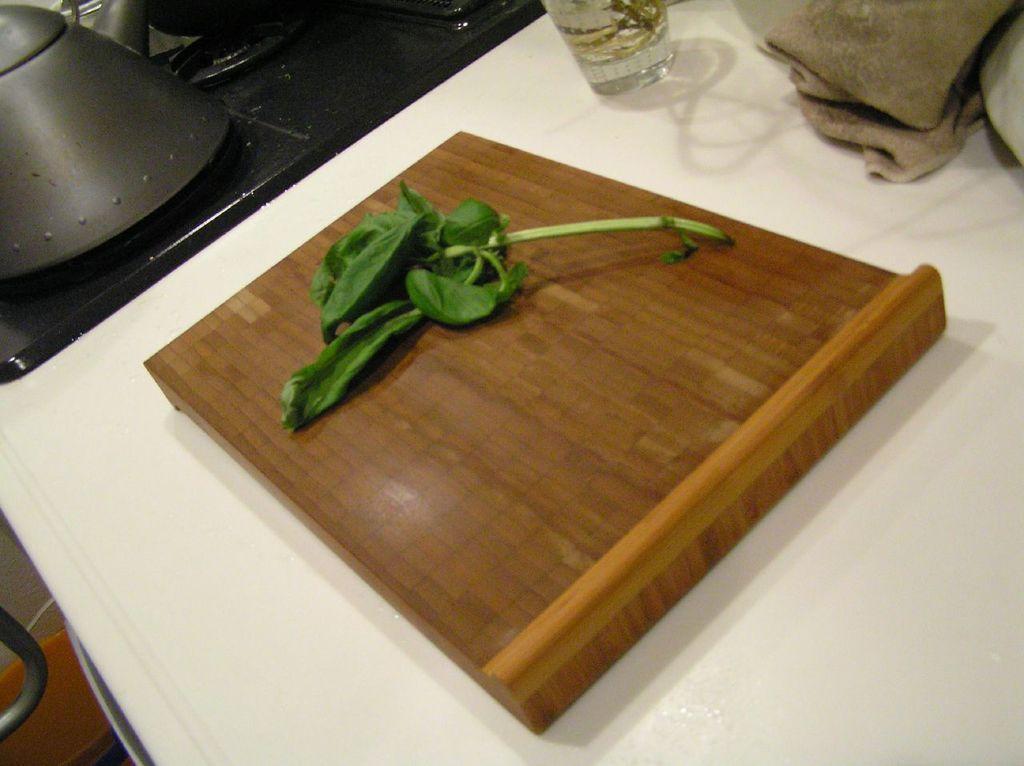How would you summarize this image in a sentence or two? In this picture I can observe a wooden plank placed on the table. I can observe leafy vegetable placed on the wooden plank. In the top of the picture I can observe glass placed on the table. 